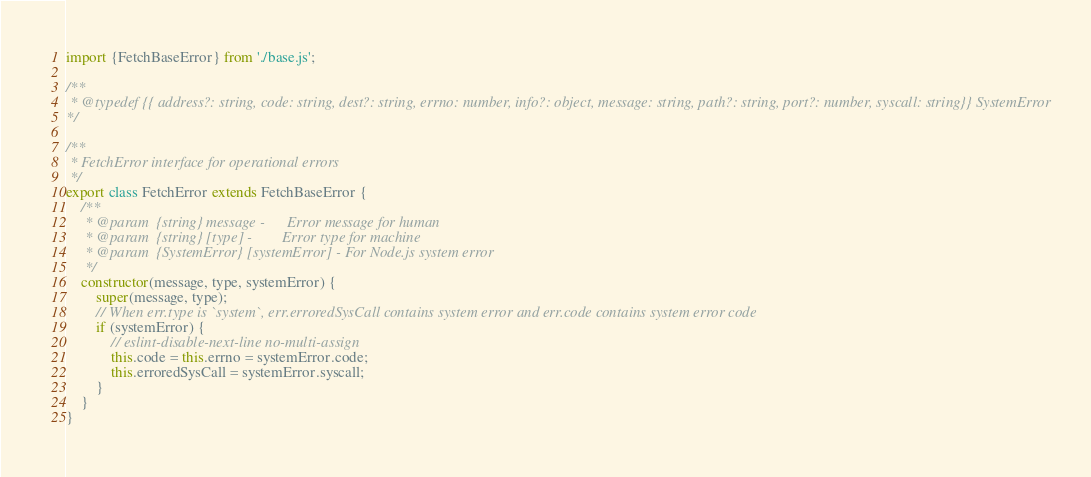Convert code to text. <code><loc_0><loc_0><loc_500><loc_500><_JavaScript_>
import {FetchBaseError} from './base.js';

/**
 * @typedef {{ address?: string, code: string, dest?: string, errno: number, info?: object, message: string, path?: string, port?: number, syscall: string}} SystemError
*/

/**
 * FetchError interface for operational errors
 */
export class FetchError extends FetchBaseError {
	/**
	 * @param  {string} message -      Error message for human
	 * @param  {string} [type] -        Error type for machine
	 * @param  {SystemError} [systemError] - For Node.js system error
	 */
	constructor(message, type, systemError) {
		super(message, type);
		// When err.type is `system`, err.erroredSysCall contains system error and err.code contains system error code
		if (systemError) {
			// eslint-disable-next-line no-multi-assign
			this.code = this.errno = systemError.code;
			this.erroredSysCall = systemError.syscall;
		}
	}
}
</code> 